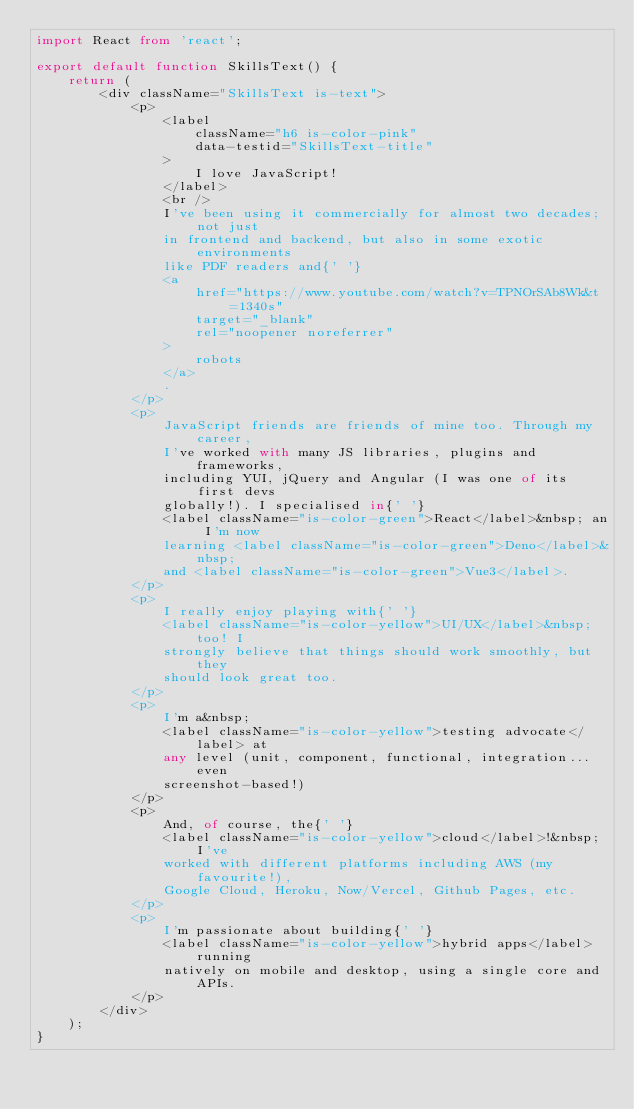Convert code to text. <code><loc_0><loc_0><loc_500><loc_500><_TypeScript_>import React from 'react';

export default function SkillsText() {
    return (
        <div className="SkillsText is-text">
            <p>
                <label
                    className="h6 is-color-pink"
                    data-testid="SkillsText-title"
                >
                    I love JavaScript!
                </label>
                <br />
                I've been using it commercially for almost two decades; not just
                in frontend and backend, but also in some exotic environments
                like PDF readers and{' '}
                <a
                    href="https://www.youtube.com/watch?v=TPNOrSAb8Wk&t=1340s"
                    target="_blank"
                    rel="noopener noreferrer"
                >
                    robots
                </a>
                .
            </p>
            <p>
                JavaScript friends are friends of mine too. Through my career,
                I've worked with many JS libraries, plugins and frameworks,
                including YUI, jQuery and Angular (I was one of its first devs
                globally!). I specialised in{' '}
                <label className="is-color-green">React</label>&nbsp; an I'm now
                learning <label className="is-color-green">Deno</label>&nbsp;
                and <label className="is-color-green">Vue3</label>.
            </p>
            <p>
                I really enjoy playing with{' '}
                <label className="is-color-yellow">UI/UX</label>&nbsp; too! I
                strongly believe that things should work smoothly, but they
                should look great too.
            </p>
            <p>
                I'm a&nbsp;
                <label className="is-color-yellow">testing advocate</label> at
                any level (unit, component, functional, integration... even
                screenshot-based!)
            </p>
            <p>
                And, of course, the{' '}
                <label className="is-color-yellow">cloud</label>!&nbsp; I've
                worked with different platforms including AWS (my favourite!),
                Google Cloud, Heroku, Now/Vercel, Github Pages, etc.
            </p>
            <p>
                I'm passionate about building{' '}
                <label className="is-color-yellow">hybrid apps</label> running
                natively on mobile and desktop, using a single core and APIs.
            </p>
        </div>
    );
}
</code> 